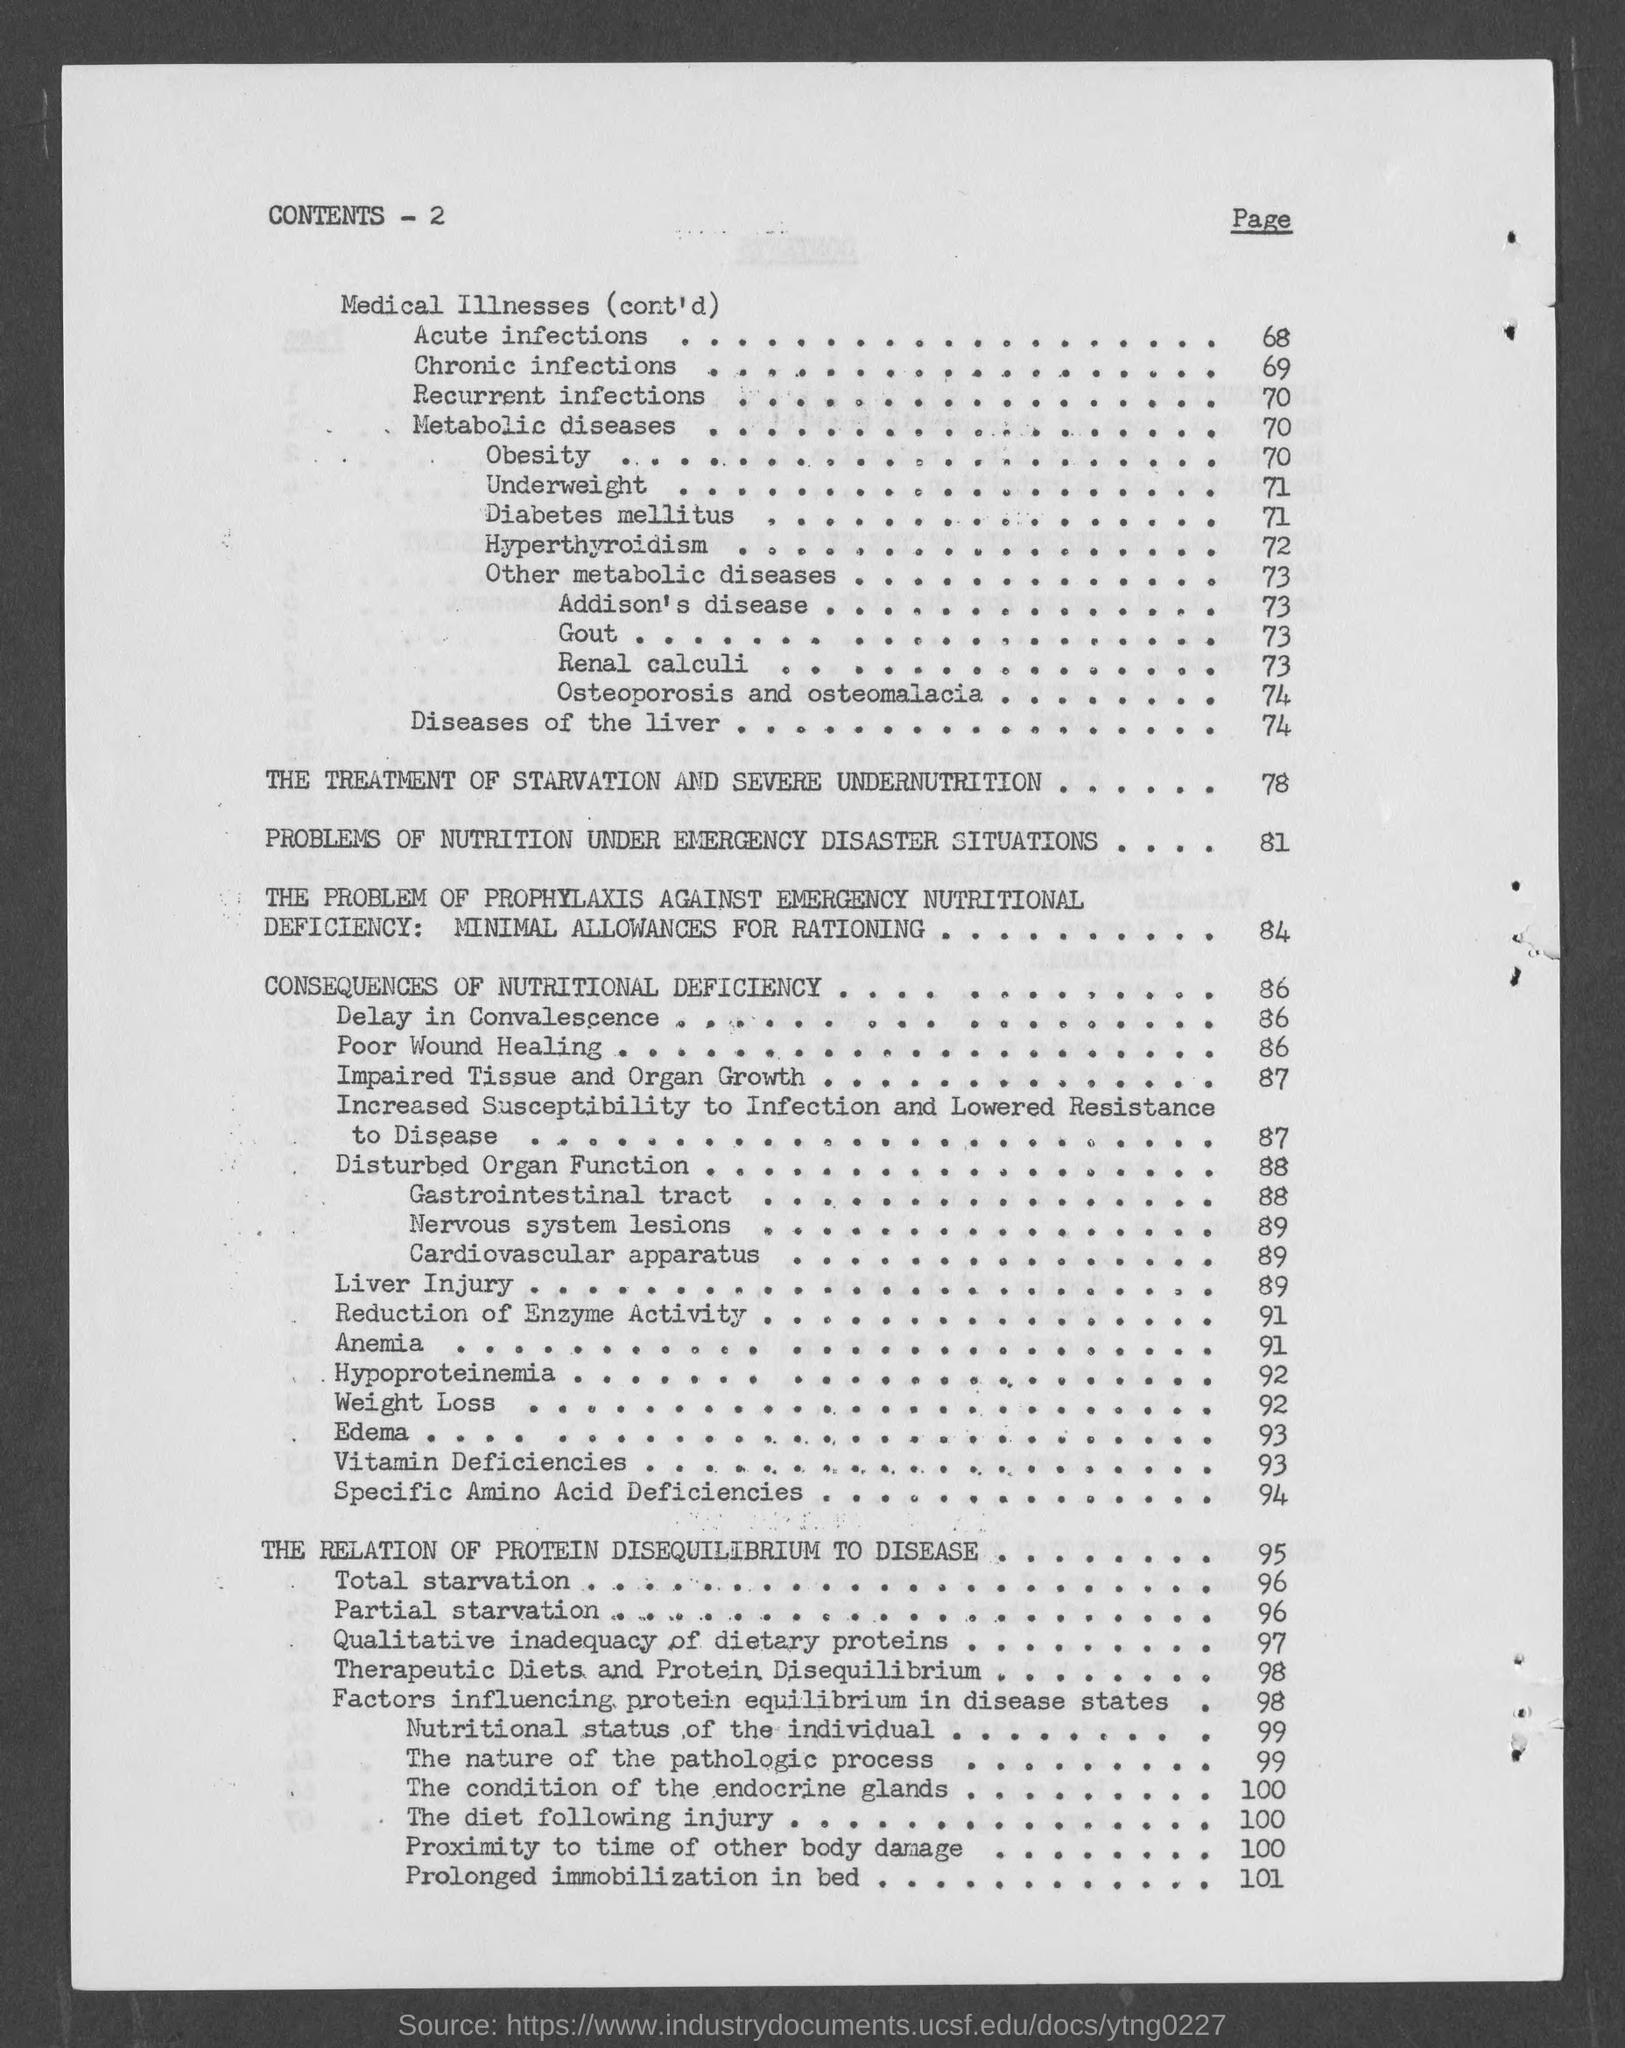In which page number is  "Chronic infections"?
Offer a very short reply. 69. In which page number is  "Recurrent infections"?
Keep it short and to the point. 70. In which page number is  "Liver Injury"?
Provide a short and direct response. 89. At 95 page what is the content?
Offer a very short reply. The relation of protein disequilibrium to disease. 